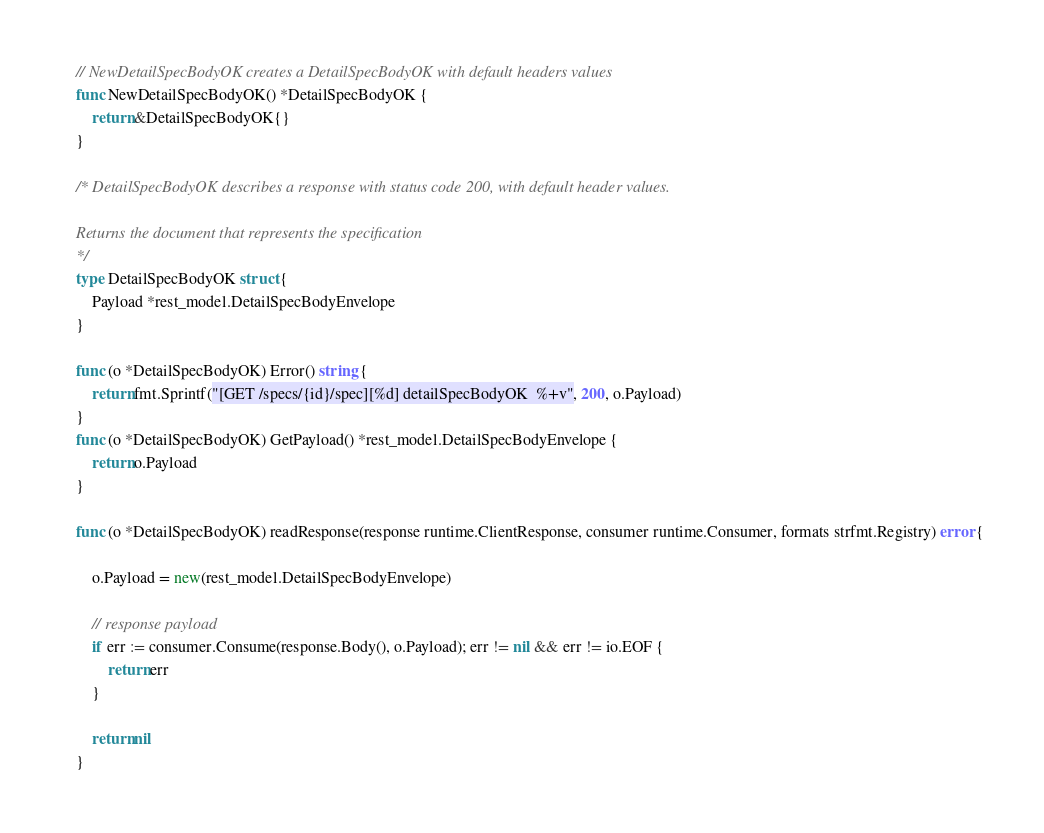<code> <loc_0><loc_0><loc_500><loc_500><_Go_>
// NewDetailSpecBodyOK creates a DetailSpecBodyOK with default headers values
func NewDetailSpecBodyOK() *DetailSpecBodyOK {
	return &DetailSpecBodyOK{}
}

/* DetailSpecBodyOK describes a response with status code 200, with default header values.

Returns the document that represents the specification
*/
type DetailSpecBodyOK struct {
	Payload *rest_model.DetailSpecBodyEnvelope
}

func (o *DetailSpecBodyOK) Error() string {
	return fmt.Sprintf("[GET /specs/{id}/spec][%d] detailSpecBodyOK  %+v", 200, o.Payload)
}
func (o *DetailSpecBodyOK) GetPayload() *rest_model.DetailSpecBodyEnvelope {
	return o.Payload
}

func (o *DetailSpecBodyOK) readResponse(response runtime.ClientResponse, consumer runtime.Consumer, formats strfmt.Registry) error {

	o.Payload = new(rest_model.DetailSpecBodyEnvelope)

	// response payload
	if err := consumer.Consume(response.Body(), o.Payload); err != nil && err != io.EOF {
		return err
	}

	return nil
}
</code> 